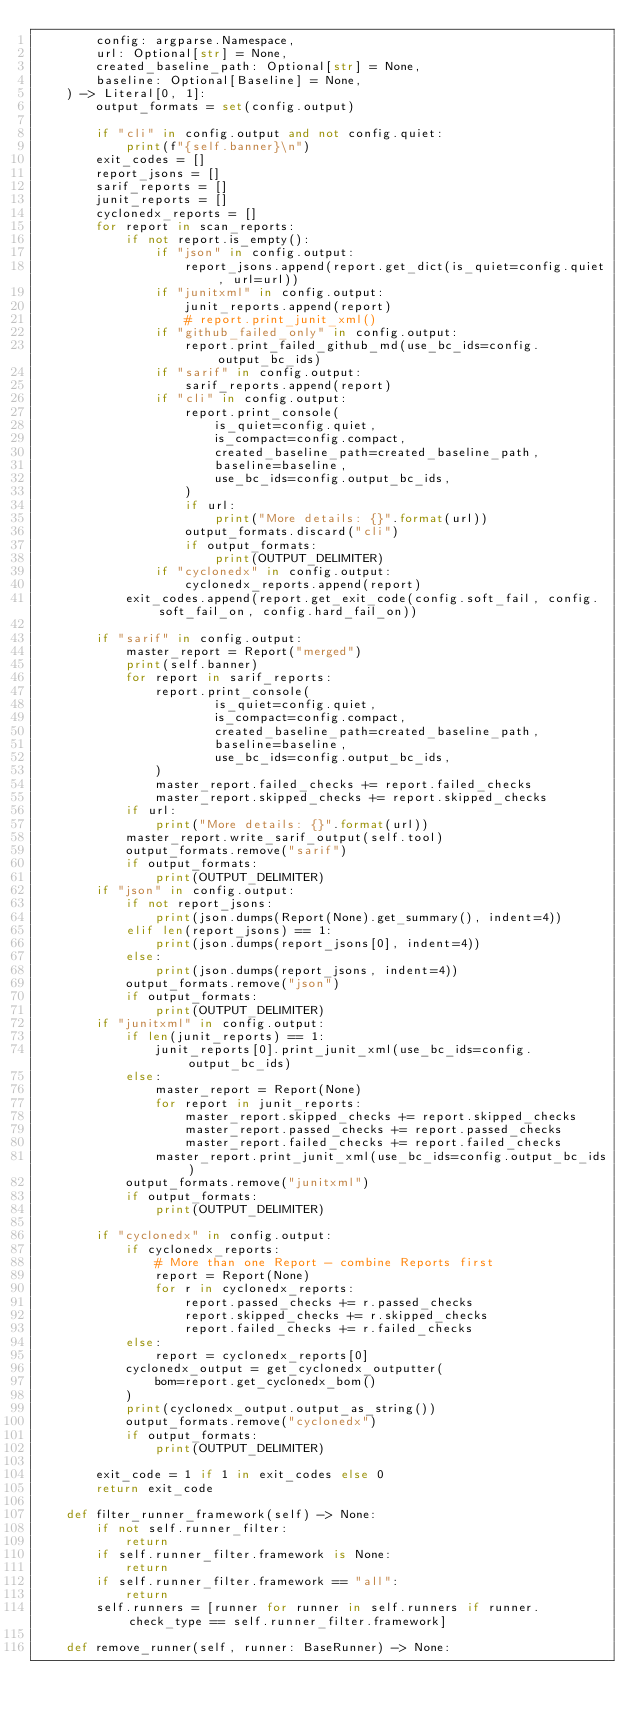<code> <loc_0><loc_0><loc_500><loc_500><_Python_>        config: argparse.Namespace,
        url: Optional[str] = None,
        created_baseline_path: Optional[str] = None,
        baseline: Optional[Baseline] = None,
    ) -> Literal[0, 1]:
        output_formats = set(config.output)

        if "cli" in config.output and not config.quiet:
            print(f"{self.banner}\n")
        exit_codes = []
        report_jsons = []
        sarif_reports = []
        junit_reports = []
        cyclonedx_reports = []
        for report in scan_reports:
            if not report.is_empty():
                if "json" in config.output:
                    report_jsons.append(report.get_dict(is_quiet=config.quiet, url=url))
                if "junitxml" in config.output:
                    junit_reports.append(report)
                    # report.print_junit_xml()
                if "github_failed_only" in config.output:
                    report.print_failed_github_md(use_bc_ids=config.output_bc_ids)
                if "sarif" in config.output:
                    sarif_reports.append(report)
                if "cli" in config.output:
                    report.print_console(
                        is_quiet=config.quiet,
                        is_compact=config.compact,
                        created_baseline_path=created_baseline_path,
                        baseline=baseline,
                        use_bc_ids=config.output_bc_ids,
                    )
                    if url:
                        print("More details: {}".format(url))
                    output_formats.discard("cli")
                    if output_formats:
                        print(OUTPUT_DELIMITER)
                if "cyclonedx" in config.output:
                    cyclonedx_reports.append(report)
            exit_codes.append(report.get_exit_code(config.soft_fail, config.soft_fail_on, config.hard_fail_on))

        if "sarif" in config.output:
            master_report = Report("merged")
            print(self.banner)
            for report in sarif_reports:
                report.print_console(
                        is_quiet=config.quiet,
                        is_compact=config.compact,
                        created_baseline_path=created_baseline_path,
                        baseline=baseline,
                        use_bc_ids=config.output_bc_ids,
                )
                master_report.failed_checks += report.failed_checks
                master_report.skipped_checks += report.skipped_checks
            if url:
                print("More details: {}".format(url))
            master_report.write_sarif_output(self.tool)
            output_formats.remove("sarif")
            if output_formats:
                print(OUTPUT_DELIMITER)
        if "json" in config.output:
            if not report_jsons:
                print(json.dumps(Report(None).get_summary(), indent=4))
            elif len(report_jsons) == 1:
                print(json.dumps(report_jsons[0], indent=4))
            else:
                print(json.dumps(report_jsons, indent=4))
            output_formats.remove("json")
            if output_formats:
                print(OUTPUT_DELIMITER)
        if "junitxml" in config.output:
            if len(junit_reports) == 1:
                junit_reports[0].print_junit_xml(use_bc_ids=config.output_bc_ids)
            else:
                master_report = Report(None)
                for report in junit_reports:
                    master_report.skipped_checks += report.skipped_checks
                    master_report.passed_checks += report.passed_checks
                    master_report.failed_checks += report.failed_checks
                master_report.print_junit_xml(use_bc_ids=config.output_bc_ids)
            output_formats.remove("junitxml")
            if output_formats:
                print(OUTPUT_DELIMITER)

        if "cyclonedx" in config.output:
            if cyclonedx_reports:
                # More than one Report - combine Reports first
                report = Report(None)
                for r in cyclonedx_reports:
                    report.passed_checks += r.passed_checks
                    report.skipped_checks += r.skipped_checks
                    report.failed_checks += r.failed_checks
            else:
                report = cyclonedx_reports[0]
            cyclonedx_output = get_cyclonedx_outputter(
                bom=report.get_cyclonedx_bom()
            )
            print(cyclonedx_output.output_as_string())
            output_formats.remove("cyclonedx")
            if output_formats:
                print(OUTPUT_DELIMITER)

        exit_code = 1 if 1 in exit_codes else 0
        return exit_code

    def filter_runner_framework(self) -> None:
        if not self.runner_filter:
            return
        if self.runner_filter.framework is None:
            return
        if self.runner_filter.framework == "all":
            return
        self.runners = [runner for runner in self.runners if runner.check_type == self.runner_filter.framework]

    def remove_runner(self, runner: BaseRunner) -> None:</code> 